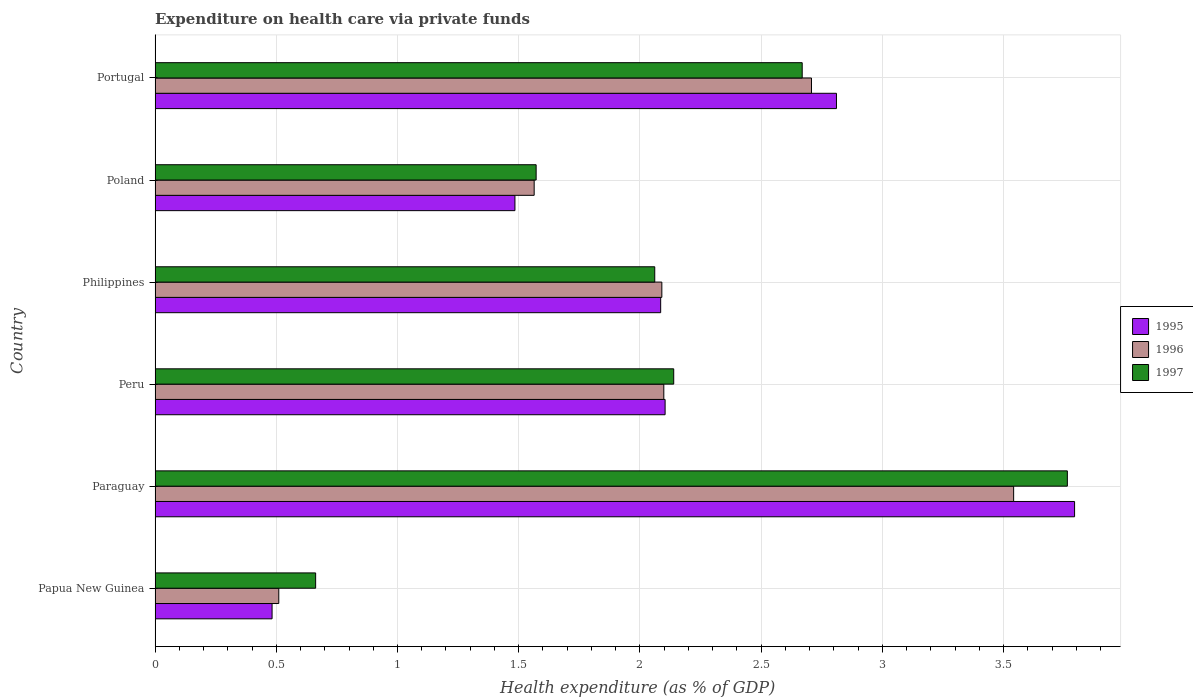Are the number of bars per tick equal to the number of legend labels?
Keep it short and to the point. Yes. Are the number of bars on each tick of the Y-axis equal?
Give a very brief answer. Yes. How many bars are there on the 4th tick from the bottom?
Your response must be concise. 3. What is the label of the 6th group of bars from the top?
Keep it short and to the point. Papua New Guinea. What is the expenditure made on health care in 1995 in Philippines?
Ensure brevity in your answer.  2.09. Across all countries, what is the maximum expenditure made on health care in 1997?
Make the answer very short. 3.76. Across all countries, what is the minimum expenditure made on health care in 1997?
Offer a very short reply. 0.66. In which country was the expenditure made on health care in 1995 maximum?
Provide a short and direct response. Paraguay. In which country was the expenditure made on health care in 1996 minimum?
Give a very brief answer. Papua New Guinea. What is the total expenditure made on health care in 1995 in the graph?
Provide a short and direct response. 12.76. What is the difference between the expenditure made on health care in 1996 in Papua New Guinea and that in Paraguay?
Your answer should be compact. -3.03. What is the difference between the expenditure made on health care in 1997 in Portugal and the expenditure made on health care in 1996 in Paraguay?
Your answer should be compact. -0.87. What is the average expenditure made on health care in 1996 per country?
Your answer should be very brief. 2.09. What is the difference between the expenditure made on health care in 1995 and expenditure made on health care in 1996 in Philippines?
Your answer should be compact. -0. In how many countries, is the expenditure made on health care in 1995 greater than 1.2 %?
Give a very brief answer. 5. What is the ratio of the expenditure made on health care in 1997 in Peru to that in Philippines?
Make the answer very short. 1.04. What is the difference between the highest and the second highest expenditure made on health care in 1997?
Offer a very short reply. 1.09. What is the difference between the highest and the lowest expenditure made on health care in 1995?
Your response must be concise. 3.31. Is it the case that in every country, the sum of the expenditure made on health care in 1995 and expenditure made on health care in 1997 is greater than the expenditure made on health care in 1996?
Provide a short and direct response. Yes. How many countries are there in the graph?
Provide a succinct answer. 6. Are the values on the major ticks of X-axis written in scientific E-notation?
Ensure brevity in your answer.  No. Does the graph contain any zero values?
Your answer should be very brief. No. How are the legend labels stacked?
Keep it short and to the point. Vertical. What is the title of the graph?
Your response must be concise. Expenditure on health care via private funds. Does "2009" appear as one of the legend labels in the graph?
Your answer should be compact. No. What is the label or title of the X-axis?
Give a very brief answer. Health expenditure (as % of GDP). What is the label or title of the Y-axis?
Make the answer very short. Country. What is the Health expenditure (as % of GDP) of 1995 in Papua New Guinea?
Make the answer very short. 0.48. What is the Health expenditure (as % of GDP) of 1996 in Papua New Guinea?
Make the answer very short. 0.51. What is the Health expenditure (as % of GDP) in 1997 in Papua New Guinea?
Ensure brevity in your answer.  0.66. What is the Health expenditure (as % of GDP) of 1995 in Paraguay?
Provide a succinct answer. 3.79. What is the Health expenditure (as % of GDP) in 1996 in Paraguay?
Offer a very short reply. 3.54. What is the Health expenditure (as % of GDP) in 1997 in Paraguay?
Make the answer very short. 3.76. What is the Health expenditure (as % of GDP) in 1995 in Peru?
Provide a succinct answer. 2.1. What is the Health expenditure (as % of GDP) of 1996 in Peru?
Offer a very short reply. 2.1. What is the Health expenditure (as % of GDP) of 1997 in Peru?
Offer a very short reply. 2.14. What is the Health expenditure (as % of GDP) of 1995 in Philippines?
Offer a terse response. 2.09. What is the Health expenditure (as % of GDP) in 1996 in Philippines?
Keep it short and to the point. 2.09. What is the Health expenditure (as % of GDP) in 1997 in Philippines?
Offer a terse response. 2.06. What is the Health expenditure (as % of GDP) in 1995 in Poland?
Offer a very short reply. 1.48. What is the Health expenditure (as % of GDP) in 1996 in Poland?
Ensure brevity in your answer.  1.56. What is the Health expenditure (as % of GDP) of 1997 in Poland?
Offer a very short reply. 1.57. What is the Health expenditure (as % of GDP) in 1995 in Portugal?
Keep it short and to the point. 2.81. What is the Health expenditure (as % of GDP) of 1996 in Portugal?
Your answer should be compact. 2.71. What is the Health expenditure (as % of GDP) in 1997 in Portugal?
Give a very brief answer. 2.67. Across all countries, what is the maximum Health expenditure (as % of GDP) of 1995?
Your answer should be compact. 3.79. Across all countries, what is the maximum Health expenditure (as % of GDP) in 1996?
Keep it short and to the point. 3.54. Across all countries, what is the maximum Health expenditure (as % of GDP) of 1997?
Ensure brevity in your answer.  3.76. Across all countries, what is the minimum Health expenditure (as % of GDP) in 1995?
Keep it short and to the point. 0.48. Across all countries, what is the minimum Health expenditure (as % of GDP) in 1996?
Give a very brief answer. 0.51. Across all countries, what is the minimum Health expenditure (as % of GDP) of 1997?
Your answer should be very brief. 0.66. What is the total Health expenditure (as % of GDP) of 1995 in the graph?
Offer a terse response. 12.76. What is the total Health expenditure (as % of GDP) in 1996 in the graph?
Give a very brief answer. 12.51. What is the total Health expenditure (as % of GDP) in 1997 in the graph?
Your answer should be very brief. 12.87. What is the difference between the Health expenditure (as % of GDP) in 1995 in Papua New Guinea and that in Paraguay?
Give a very brief answer. -3.31. What is the difference between the Health expenditure (as % of GDP) of 1996 in Papua New Guinea and that in Paraguay?
Your response must be concise. -3.03. What is the difference between the Health expenditure (as % of GDP) in 1997 in Papua New Guinea and that in Paraguay?
Keep it short and to the point. -3.1. What is the difference between the Health expenditure (as % of GDP) of 1995 in Papua New Guinea and that in Peru?
Provide a short and direct response. -1.62. What is the difference between the Health expenditure (as % of GDP) in 1996 in Papua New Guinea and that in Peru?
Your response must be concise. -1.59. What is the difference between the Health expenditure (as % of GDP) of 1997 in Papua New Guinea and that in Peru?
Offer a terse response. -1.48. What is the difference between the Health expenditure (as % of GDP) in 1995 in Papua New Guinea and that in Philippines?
Offer a terse response. -1.6. What is the difference between the Health expenditure (as % of GDP) in 1996 in Papua New Guinea and that in Philippines?
Give a very brief answer. -1.58. What is the difference between the Health expenditure (as % of GDP) of 1997 in Papua New Guinea and that in Philippines?
Ensure brevity in your answer.  -1.4. What is the difference between the Health expenditure (as % of GDP) of 1995 in Papua New Guinea and that in Poland?
Make the answer very short. -1. What is the difference between the Health expenditure (as % of GDP) of 1996 in Papua New Guinea and that in Poland?
Make the answer very short. -1.05. What is the difference between the Health expenditure (as % of GDP) in 1997 in Papua New Guinea and that in Poland?
Ensure brevity in your answer.  -0.91. What is the difference between the Health expenditure (as % of GDP) in 1995 in Papua New Guinea and that in Portugal?
Offer a terse response. -2.33. What is the difference between the Health expenditure (as % of GDP) of 1996 in Papua New Guinea and that in Portugal?
Your response must be concise. -2.2. What is the difference between the Health expenditure (as % of GDP) in 1997 in Papua New Guinea and that in Portugal?
Your answer should be compact. -2.01. What is the difference between the Health expenditure (as % of GDP) in 1995 in Paraguay and that in Peru?
Your response must be concise. 1.69. What is the difference between the Health expenditure (as % of GDP) of 1996 in Paraguay and that in Peru?
Provide a short and direct response. 1.44. What is the difference between the Health expenditure (as % of GDP) in 1997 in Paraguay and that in Peru?
Your response must be concise. 1.62. What is the difference between the Health expenditure (as % of GDP) in 1995 in Paraguay and that in Philippines?
Offer a very short reply. 1.71. What is the difference between the Health expenditure (as % of GDP) of 1996 in Paraguay and that in Philippines?
Give a very brief answer. 1.45. What is the difference between the Health expenditure (as % of GDP) in 1997 in Paraguay and that in Philippines?
Make the answer very short. 1.7. What is the difference between the Health expenditure (as % of GDP) of 1995 in Paraguay and that in Poland?
Make the answer very short. 2.31. What is the difference between the Health expenditure (as % of GDP) in 1996 in Paraguay and that in Poland?
Your response must be concise. 1.98. What is the difference between the Health expenditure (as % of GDP) in 1997 in Paraguay and that in Poland?
Make the answer very short. 2.19. What is the difference between the Health expenditure (as % of GDP) in 1995 in Paraguay and that in Portugal?
Provide a short and direct response. 0.98. What is the difference between the Health expenditure (as % of GDP) in 1996 in Paraguay and that in Portugal?
Your response must be concise. 0.83. What is the difference between the Health expenditure (as % of GDP) in 1997 in Paraguay and that in Portugal?
Ensure brevity in your answer.  1.09. What is the difference between the Health expenditure (as % of GDP) of 1995 in Peru and that in Philippines?
Your answer should be very brief. 0.02. What is the difference between the Health expenditure (as % of GDP) in 1996 in Peru and that in Philippines?
Your answer should be compact. 0.01. What is the difference between the Health expenditure (as % of GDP) of 1997 in Peru and that in Philippines?
Your response must be concise. 0.08. What is the difference between the Health expenditure (as % of GDP) in 1995 in Peru and that in Poland?
Provide a succinct answer. 0.62. What is the difference between the Health expenditure (as % of GDP) in 1996 in Peru and that in Poland?
Your response must be concise. 0.53. What is the difference between the Health expenditure (as % of GDP) in 1997 in Peru and that in Poland?
Offer a very short reply. 0.57. What is the difference between the Health expenditure (as % of GDP) in 1995 in Peru and that in Portugal?
Provide a short and direct response. -0.71. What is the difference between the Health expenditure (as % of GDP) of 1996 in Peru and that in Portugal?
Provide a succinct answer. -0.61. What is the difference between the Health expenditure (as % of GDP) in 1997 in Peru and that in Portugal?
Offer a terse response. -0.53. What is the difference between the Health expenditure (as % of GDP) of 1995 in Philippines and that in Poland?
Make the answer very short. 0.6. What is the difference between the Health expenditure (as % of GDP) of 1996 in Philippines and that in Poland?
Offer a terse response. 0.53. What is the difference between the Health expenditure (as % of GDP) in 1997 in Philippines and that in Poland?
Offer a terse response. 0.49. What is the difference between the Health expenditure (as % of GDP) of 1995 in Philippines and that in Portugal?
Give a very brief answer. -0.73. What is the difference between the Health expenditure (as % of GDP) of 1996 in Philippines and that in Portugal?
Offer a terse response. -0.62. What is the difference between the Health expenditure (as % of GDP) in 1997 in Philippines and that in Portugal?
Keep it short and to the point. -0.61. What is the difference between the Health expenditure (as % of GDP) in 1995 in Poland and that in Portugal?
Your response must be concise. -1.33. What is the difference between the Health expenditure (as % of GDP) of 1996 in Poland and that in Portugal?
Make the answer very short. -1.14. What is the difference between the Health expenditure (as % of GDP) of 1997 in Poland and that in Portugal?
Your answer should be very brief. -1.1. What is the difference between the Health expenditure (as % of GDP) in 1995 in Papua New Guinea and the Health expenditure (as % of GDP) in 1996 in Paraguay?
Provide a succinct answer. -3.06. What is the difference between the Health expenditure (as % of GDP) in 1995 in Papua New Guinea and the Health expenditure (as % of GDP) in 1997 in Paraguay?
Your answer should be very brief. -3.28. What is the difference between the Health expenditure (as % of GDP) of 1996 in Papua New Guinea and the Health expenditure (as % of GDP) of 1997 in Paraguay?
Offer a very short reply. -3.25. What is the difference between the Health expenditure (as % of GDP) in 1995 in Papua New Guinea and the Health expenditure (as % of GDP) in 1996 in Peru?
Provide a succinct answer. -1.62. What is the difference between the Health expenditure (as % of GDP) in 1995 in Papua New Guinea and the Health expenditure (as % of GDP) in 1997 in Peru?
Offer a very short reply. -1.66. What is the difference between the Health expenditure (as % of GDP) of 1996 in Papua New Guinea and the Health expenditure (as % of GDP) of 1997 in Peru?
Provide a succinct answer. -1.63. What is the difference between the Health expenditure (as % of GDP) in 1995 in Papua New Guinea and the Health expenditure (as % of GDP) in 1996 in Philippines?
Give a very brief answer. -1.61. What is the difference between the Health expenditure (as % of GDP) of 1995 in Papua New Guinea and the Health expenditure (as % of GDP) of 1997 in Philippines?
Make the answer very short. -1.58. What is the difference between the Health expenditure (as % of GDP) of 1996 in Papua New Guinea and the Health expenditure (as % of GDP) of 1997 in Philippines?
Ensure brevity in your answer.  -1.55. What is the difference between the Health expenditure (as % of GDP) of 1995 in Papua New Guinea and the Health expenditure (as % of GDP) of 1996 in Poland?
Ensure brevity in your answer.  -1.08. What is the difference between the Health expenditure (as % of GDP) of 1995 in Papua New Guinea and the Health expenditure (as % of GDP) of 1997 in Poland?
Make the answer very short. -1.09. What is the difference between the Health expenditure (as % of GDP) of 1996 in Papua New Guinea and the Health expenditure (as % of GDP) of 1997 in Poland?
Provide a succinct answer. -1.06. What is the difference between the Health expenditure (as % of GDP) of 1995 in Papua New Guinea and the Health expenditure (as % of GDP) of 1996 in Portugal?
Your response must be concise. -2.23. What is the difference between the Health expenditure (as % of GDP) in 1995 in Papua New Guinea and the Health expenditure (as % of GDP) in 1997 in Portugal?
Ensure brevity in your answer.  -2.19. What is the difference between the Health expenditure (as % of GDP) in 1996 in Papua New Guinea and the Health expenditure (as % of GDP) in 1997 in Portugal?
Give a very brief answer. -2.16. What is the difference between the Health expenditure (as % of GDP) in 1995 in Paraguay and the Health expenditure (as % of GDP) in 1996 in Peru?
Your answer should be compact. 1.69. What is the difference between the Health expenditure (as % of GDP) of 1995 in Paraguay and the Health expenditure (as % of GDP) of 1997 in Peru?
Give a very brief answer. 1.65. What is the difference between the Health expenditure (as % of GDP) of 1996 in Paraguay and the Health expenditure (as % of GDP) of 1997 in Peru?
Your answer should be compact. 1.4. What is the difference between the Health expenditure (as % of GDP) of 1995 in Paraguay and the Health expenditure (as % of GDP) of 1996 in Philippines?
Provide a succinct answer. 1.7. What is the difference between the Health expenditure (as % of GDP) of 1995 in Paraguay and the Health expenditure (as % of GDP) of 1997 in Philippines?
Ensure brevity in your answer.  1.73. What is the difference between the Health expenditure (as % of GDP) of 1996 in Paraguay and the Health expenditure (as % of GDP) of 1997 in Philippines?
Provide a short and direct response. 1.48. What is the difference between the Health expenditure (as % of GDP) in 1995 in Paraguay and the Health expenditure (as % of GDP) in 1996 in Poland?
Your answer should be compact. 2.23. What is the difference between the Health expenditure (as % of GDP) in 1995 in Paraguay and the Health expenditure (as % of GDP) in 1997 in Poland?
Offer a terse response. 2.22. What is the difference between the Health expenditure (as % of GDP) in 1996 in Paraguay and the Health expenditure (as % of GDP) in 1997 in Poland?
Offer a terse response. 1.97. What is the difference between the Health expenditure (as % of GDP) in 1995 in Paraguay and the Health expenditure (as % of GDP) in 1996 in Portugal?
Your answer should be very brief. 1.09. What is the difference between the Health expenditure (as % of GDP) of 1995 in Paraguay and the Health expenditure (as % of GDP) of 1997 in Portugal?
Your answer should be compact. 1.12. What is the difference between the Health expenditure (as % of GDP) of 1996 in Paraguay and the Health expenditure (as % of GDP) of 1997 in Portugal?
Provide a short and direct response. 0.87. What is the difference between the Health expenditure (as % of GDP) in 1995 in Peru and the Health expenditure (as % of GDP) in 1996 in Philippines?
Provide a short and direct response. 0.01. What is the difference between the Health expenditure (as % of GDP) of 1995 in Peru and the Health expenditure (as % of GDP) of 1997 in Philippines?
Offer a terse response. 0.04. What is the difference between the Health expenditure (as % of GDP) in 1996 in Peru and the Health expenditure (as % of GDP) in 1997 in Philippines?
Offer a terse response. 0.04. What is the difference between the Health expenditure (as % of GDP) in 1995 in Peru and the Health expenditure (as % of GDP) in 1996 in Poland?
Make the answer very short. 0.54. What is the difference between the Health expenditure (as % of GDP) of 1995 in Peru and the Health expenditure (as % of GDP) of 1997 in Poland?
Make the answer very short. 0.53. What is the difference between the Health expenditure (as % of GDP) in 1996 in Peru and the Health expenditure (as % of GDP) in 1997 in Poland?
Provide a succinct answer. 0.53. What is the difference between the Health expenditure (as % of GDP) in 1995 in Peru and the Health expenditure (as % of GDP) in 1996 in Portugal?
Provide a short and direct response. -0.6. What is the difference between the Health expenditure (as % of GDP) of 1995 in Peru and the Health expenditure (as % of GDP) of 1997 in Portugal?
Your answer should be compact. -0.57. What is the difference between the Health expenditure (as % of GDP) of 1996 in Peru and the Health expenditure (as % of GDP) of 1997 in Portugal?
Your answer should be very brief. -0.57. What is the difference between the Health expenditure (as % of GDP) of 1995 in Philippines and the Health expenditure (as % of GDP) of 1996 in Poland?
Make the answer very short. 0.52. What is the difference between the Health expenditure (as % of GDP) in 1995 in Philippines and the Health expenditure (as % of GDP) in 1997 in Poland?
Provide a short and direct response. 0.51. What is the difference between the Health expenditure (as % of GDP) in 1996 in Philippines and the Health expenditure (as % of GDP) in 1997 in Poland?
Ensure brevity in your answer.  0.52. What is the difference between the Health expenditure (as % of GDP) of 1995 in Philippines and the Health expenditure (as % of GDP) of 1996 in Portugal?
Ensure brevity in your answer.  -0.62. What is the difference between the Health expenditure (as % of GDP) of 1995 in Philippines and the Health expenditure (as % of GDP) of 1997 in Portugal?
Your answer should be compact. -0.58. What is the difference between the Health expenditure (as % of GDP) of 1996 in Philippines and the Health expenditure (as % of GDP) of 1997 in Portugal?
Give a very brief answer. -0.58. What is the difference between the Health expenditure (as % of GDP) in 1995 in Poland and the Health expenditure (as % of GDP) in 1996 in Portugal?
Offer a terse response. -1.22. What is the difference between the Health expenditure (as % of GDP) in 1995 in Poland and the Health expenditure (as % of GDP) in 1997 in Portugal?
Offer a very short reply. -1.18. What is the difference between the Health expenditure (as % of GDP) in 1996 in Poland and the Health expenditure (as % of GDP) in 1997 in Portugal?
Offer a very short reply. -1.11. What is the average Health expenditure (as % of GDP) of 1995 per country?
Your answer should be compact. 2.13. What is the average Health expenditure (as % of GDP) of 1996 per country?
Your answer should be compact. 2.09. What is the average Health expenditure (as % of GDP) of 1997 per country?
Your answer should be compact. 2.14. What is the difference between the Health expenditure (as % of GDP) in 1995 and Health expenditure (as % of GDP) in 1996 in Papua New Guinea?
Ensure brevity in your answer.  -0.03. What is the difference between the Health expenditure (as % of GDP) of 1995 and Health expenditure (as % of GDP) of 1997 in Papua New Guinea?
Offer a very short reply. -0.18. What is the difference between the Health expenditure (as % of GDP) in 1996 and Health expenditure (as % of GDP) in 1997 in Papua New Guinea?
Offer a very short reply. -0.15. What is the difference between the Health expenditure (as % of GDP) of 1995 and Health expenditure (as % of GDP) of 1996 in Paraguay?
Make the answer very short. 0.25. What is the difference between the Health expenditure (as % of GDP) in 1995 and Health expenditure (as % of GDP) in 1997 in Paraguay?
Offer a very short reply. 0.03. What is the difference between the Health expenditure (as % of GDP) of 1996 and Health expenditure (as % of GDP) of 1997 in Paraguay?
Give a very brief answer. -0.22. What is the difference between the Health expenditure (as % of GDP) in 1995 and Health expenditure (as % of GDP) in 1996 in Peru?
Give a very brief answer. 0.01. What is the difference between the Health expenditure (as % of GDP) in 1995 and Health expenditure (as % of GDP) in 1997 in Peru?
Make the answer very short. -0.04. What is the difference between the Health expenditure (as % of GDP) in 1996 and Health expenditure (as % of GDP) in 1997 in Peru?
Provide a short and direct response. -0.04. What is the difference between the Health expenditure (as % of GDP) of 1995 and Health expenditure (as % of GDP) of 1996 in Philippines?
Offer a very short reply. -0. What is the difference between the Health expenditure (as % of GDP) of 1995 and Health expenditure (as % of GDP) of 1997 in Philippines?
Your response must be concise. 0.02. What is the difference between the Health expenditure (as % of GDP) in 1996 and Health expenditure (as % of GDP) in 1997 in Philippines?
Your answer should be compact. 0.03. What is the difference between the Health expenditure (as % of GDP) in 1995 and Health expenditure (as % of GDP) in 1996 in Poland?
Offer a very short reply. -0.08. What is the difference between the Health expenditure (as % of GDP) of 1995 and Health expenditure (as % of GDP) of 1997 in Poland?
Offer a terse response. -0.09. What is the difference between the Health expenditure (as % of GDP) of 1996 and Health expenditure (as % of GDP) of 1997 in Poland?
Keep it short and to the point. -0.01. What is the difference between the Health expenditure (as % of GDP) in 1995 and Health expenditure (as % of GDP) in 1996 in Portugal?
Make the answer very short. 0.1. What is the difference between the Health expenditure (as % of GDP) in 1995 and Health expenditure (as % of GDP) in 1997 in Portugal?
Offer a very short reply. 0.14. What is the difference between the Health expenditure (as % of GDP) in 1996 and Health expenditure (as % of GDP) in 1997 in Portugal?
Provide a short and direct response. 0.04. What is the ratio of the Health expenditure (as % of GDP) of 1995 in Papua New Guinea to that in Paraguay?
Offer a terse response. 0.13. What is the ratio of the Health expenditure (as % of GDP) of 1996 in Papua New Guinea to that in Paraguay?
Your answer should be very brief. 0.14. What is the ratio of the Health expenditure (as % of GDP) of 1997 in Papua New Guinea to that in Paraguay?
Offer a very short reply. 0.18. What is the ratio of the Health expenditure (as % of GDP) of 1995 in Papua New Guinea to that in Peru?
Make the answer very short. 0.23. What is the ratio of the Health expenditure (as % of GDP) in 1996 in Papua New Guinea to that in Peru?
Ensure brevity in your answer.  0.24. What is the ratio of the Health expenditure (as % of GDP) in 1997 in Papua New Guinea to that in Peru?
Your response must be concise. 0.31. What is the ratio of the Health expenditure (as % of GDP) of 1995 in Papua New Guinea to that in Philippines?
Offer a terse response. 0.23. What is the ratio of the Health expenditure (as % of GDP) of 1996 in Papua New Guinea to that in Philippines?
Ensure brevity in your answer.  0.24. What is the ratio of the Health expenditure (as % of GDP) of 1997 in Papua New Guinea to that in Philippines?
Make the answer very short. 0.32. What is the ratio of the Health expenditure (as % of GDP) in 1995 in Papua New Guinea to that in Poland?
Offer a very short reply. 0.33. What is the ratio of the Health expenditure (as % of GDP) of 1996 in Papua New Guinea to that in Poland?
Your response must be concise. 0.33. What is the ratio of the Health expenditure (as % of GDP) of 1997 in Papua New Guinea to that in Poland?
Your response must be concise. 0.42. What is the ratio of the Health expenditure (as % of GDP) of 1995 in Papua New Guinea to that in Portugal?
Keep it short and to the point. 0.17. What is the ratio of the Health expenditure (as % of GDP) in 1996 in Papua New Guinea to that in Portugal?
Provide a short and direct response. 0.19. What is the ratio of the Health expenditure (as % of GDP) in 1997 in Papua New Guinea to that in Portugal?
Provide a succinct answer. 0.25. What is the ratio of the Health expenditure (as % of GDP) in 1995 in Paraguay to that in Peru?
Your answer should be compact. 1.8. What is the ratio of the Health expenditure (as % of GDP) of 1996 in Paraguay to that in Peru?
Your response must be concise. 1.69. What is the ratio of the Health expenditure (as % of GDP) of 1997 in Paraguay to that in Peru?
Your answer should be very brief. 1.76. What is the ratio of the Health expenditure (as % of GDP) in 1995 in Paraguay to that in Philippines?
Provide a short and direct response. 1.82. What is the ratio of the Health expenditure (as % of GDP) of 1996 in Paraguay to that in Philippines?
Provide a succinct answer. 1.69. What is the ratio of the Health expenditure (as % of GDP) of 1997 in Paraguay to that in Philippines?
Ensure brevity in your answer.  1.83. What is the ratio of the Health expenditure (as % of GDP) in 1995 in Paraguay to that in Poland?
Your response must be concise. 2.56. What is the ratio of the Health expenditure (as % of GDP) in 1996 in Paraguay to that in Poland?
Your answer should be very brief. 2.26. What is the ratio of the Health expenditure (as % of GDP) in 1997 in Paraguay to that in Poland?
Your answer should be compact. 2.39. What is the ratio of the Health expenditure (as % of GDP) of 1995 in Paraguay to that in Portugal?
Your answer should be very brief. 1.35. What is the ratio of the Health expenditure (as % of GDP) of 1996 in Paraguay to that in Portugal?
Give a very brief answer. 1.31. What is the ratio of the Health expenditure (as % of GDP) of 1997 in Paraguay to that in Portugal?
Your answer should be very brief. 1.41. What is the ratio of the Health expenditure (as % of GDP) in 1995 in Peru to that in Philippines?
Provide a succinct answer. 1.01. What is the ratio of the Health expenditure (as % of GDP) in 1996 in Peru to that in Philippines?
Provide a succinct answer. 1. What is the ratio of the Health expenditure (as % of GDP) in 1997 in Peru to that in Philippines?
Provide a succinct answer. 1.04. What is the ratio of the Health expenditure (as % of GDP) of 1995 in Peru to that in Poland?
Your answer should be very brief. 1.42. What is the ratio of the Health expenditure (as % of GDP) in 1996 in Peru to that in Poland?
Provide a succinct answer. 1.34. What is the ratio of the Health expenditure (as % of GDP) of 1997 in Peru to that in Poland?
Your answer should be compact. 1.36. What is the ratio of the Health expenditure (as % of GDP) of 1995 in Peru to that in Portugal?
Make the answer very short. 0.75. What is the ratio of the Health expenditure (as % of GDP) of 1996 in Peru to that in Portugal?
Your answer should be compact. 0.78. What is the ratio of the Health expenditure (as % of GDP) in 1997 in Peru to that in Portugal?
Offer a terse response. 0.8. What is the ratio of the Health expenditure (as % of GDP) in 1995 in Philippines to that in Poland?
Give a very brief answer. 1.41. What is the ratio of the Health expenditure (as % of GDP) in 1996 in Philippines to that in Poland?
Offer a terse response. 1.34. What is the ratio of the Health expenditure (as % of GDP) of 1997 in Philippines to that in Poland?
Your response must be concise. 1.31. What is the ratio of the Health expenditure (as % of GDP) of 1995 in Philippines to that in Portugal?
Provide a succinct answer. 0.74. What is the ratio of the Health expenditure (as % of GDP) of 1996 in Philippines to that in Portugal?
Offer a terse response. 0.77. What is the ratio of the Health expenditure (as % of GDP) of 1997 in Philippines to that in Portugal?
Offer a terse response. 0.77. What is the ratio of the Health expenditure (as % of GDP) of 1995 in Poland to that in Portugal?
Offer a terse response. 0.53. What is the ratio of the Health expenditure (as % of GDP) of 1996 in Poland to that in Portugal?
Offer a very short reply. 0.58. What is the ratio of the Health expenditure (as % of GDP) in 1997 in Poland to that in Portugal?
Make the answer very short. 0.59. What is the difference between the highest and the second highest Health expenditure (as % of GDP) of 1995?
Provide a short and direct response. 0.98. What is the difference between the highest and the second highest Health expenditure (as % of GDP) in 1996?
Offer a terse response. 0.83. What is the difference between the highest and the second highest Health expenditure (as % of GDP) of 1997?
Keep it short and to the point. 1.09. What is the difference between the highest and the lowest Health expenditure (as % of GDP) in 1995?
Your answer should be very brief. 3.31. What is the difference between the highest and the lowest Health expenditure (as % of GDP) in 1996?
Offer a terse response. 3.03. What is the difference between the highest and the lowest Health expenditure (as % of GDP) in 1997?
Provide a short and direct response. 3.1. 